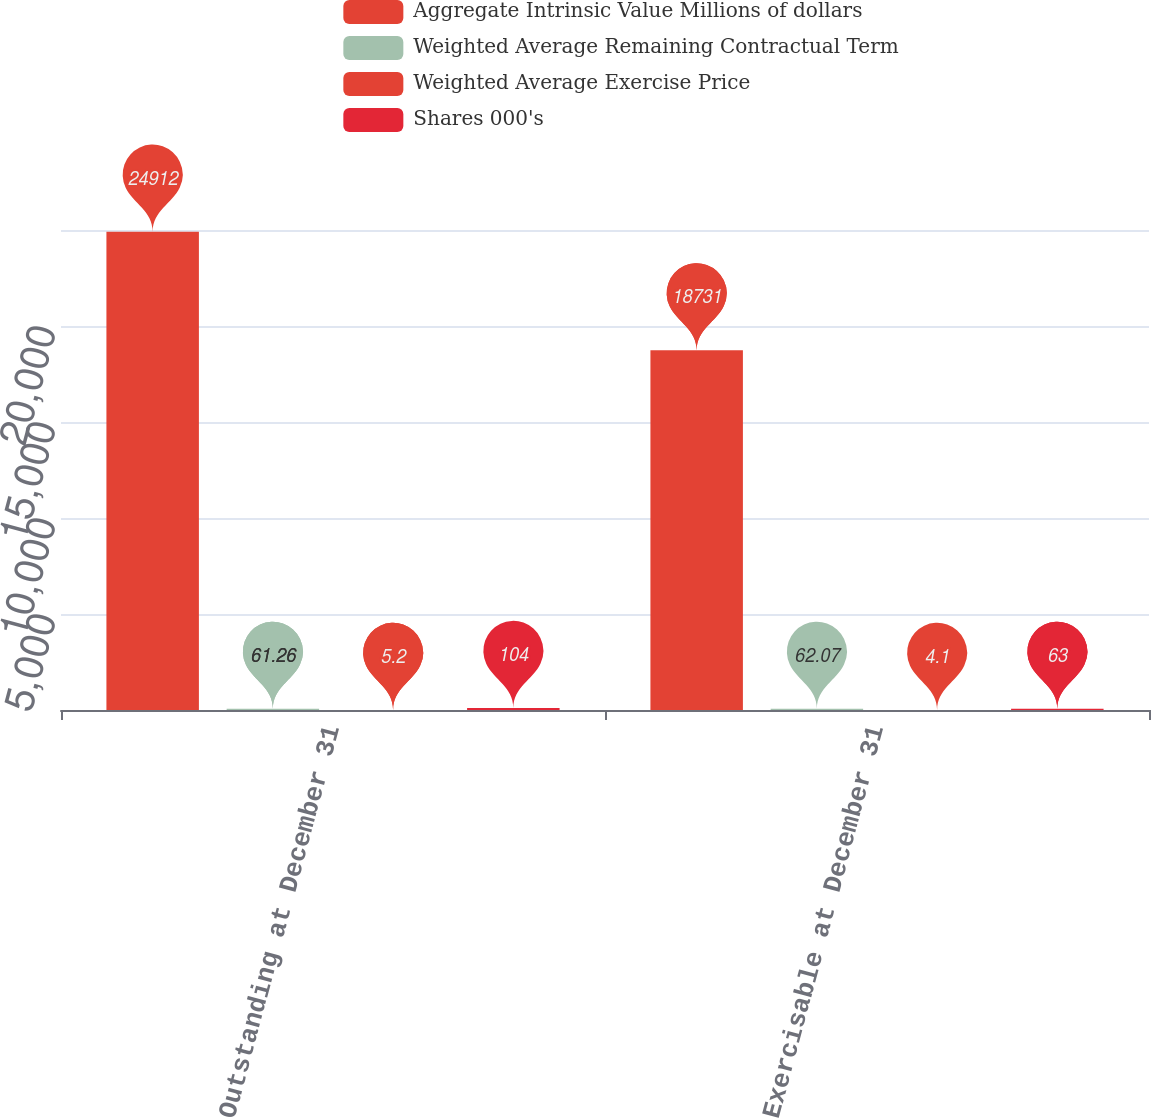Convert chart. <chart><loc_0><loc_0><loc_500><loc_500><stacked_bar_chart><ecel><fcel>Outstanding at December 31<fcel>Exercisable at December 31<nl><fcel>Aggregate Intrinsic Value Millions of dollars<fcel>24912<fcel>18731<nl><fcel>Weighted Average Remaining Contractual Term<fcel>61.26<fcel>62.07<nl><fcel>Weighted Average Exercise Price<fcel>5.2<fcel>4.1<nl><fcel>Shares 000's<fcel>104<fcel>63<nl></chart> 